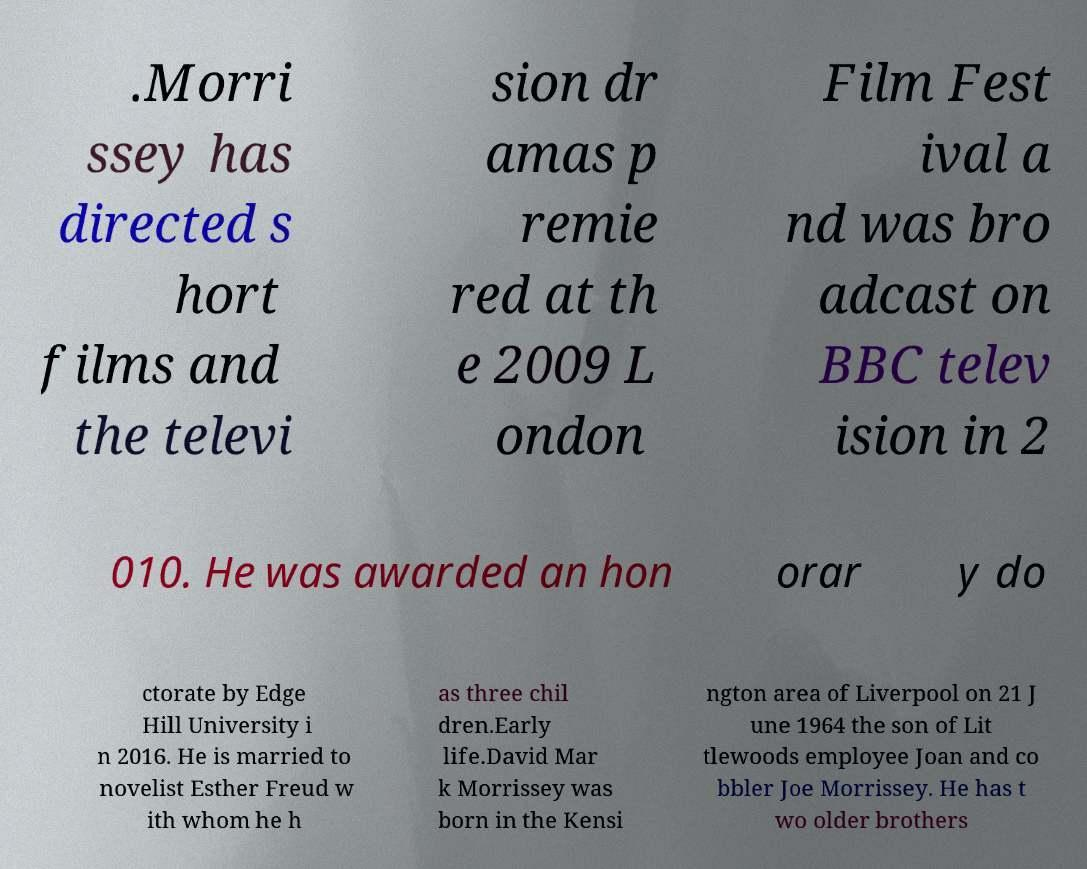Please read and relay the text visible in this image. What does it say? .Morri ssey has directed s hort films and the televi sion dr amas p remie red at th e 2009 L ondon Film Fest ival a nd was bro adcast on BBC telev ision in 2 010. He was awarded an hon orar y do ctorate by Edge Hill University i n 2016. He is married to novelist Esther Freud w ith whom he h as three chil dren.Early life.David Mar k Morrissey was born in the Kensi ngton area of Liverpool on 21 J une 1964 the son of Lit tlewoods employee Joan and co bbler Joe Morrissey. He has t wo older brothers 